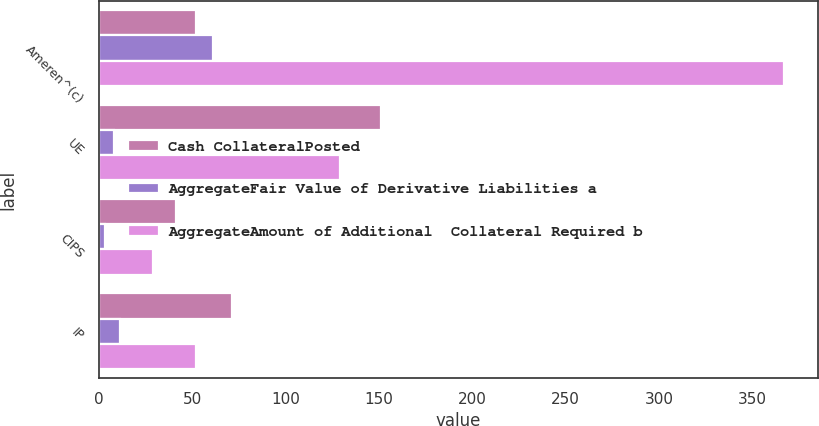Convert chart. <chart><loc_0><loc_0><loc_500><loc_500><stacked_bar_chart><ecel><fcel>Ameren^(c)<fcel>UE<fcel>CIPS<fcel>IP<nl><fcel>Cash CollateralPosted<fcel>52<fcel>151<fcel>41<fcel>71<nl><fcel>AggregateFair Value of Derivative Liabilities a<fcel>61<fcel>8<fcel>3<fcel>11<nl><fcel>AggregateAmount of Additional  Collateral Required b<fcel>367<fcel>129<fcel>29<fcel>52<nl></chart> 